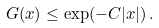Convert formula to latex. <formula><loc_0><loc_0><loc_500><loc_500>G ( x ) \leq \exp ( - C | x | ) \, .</formula> 